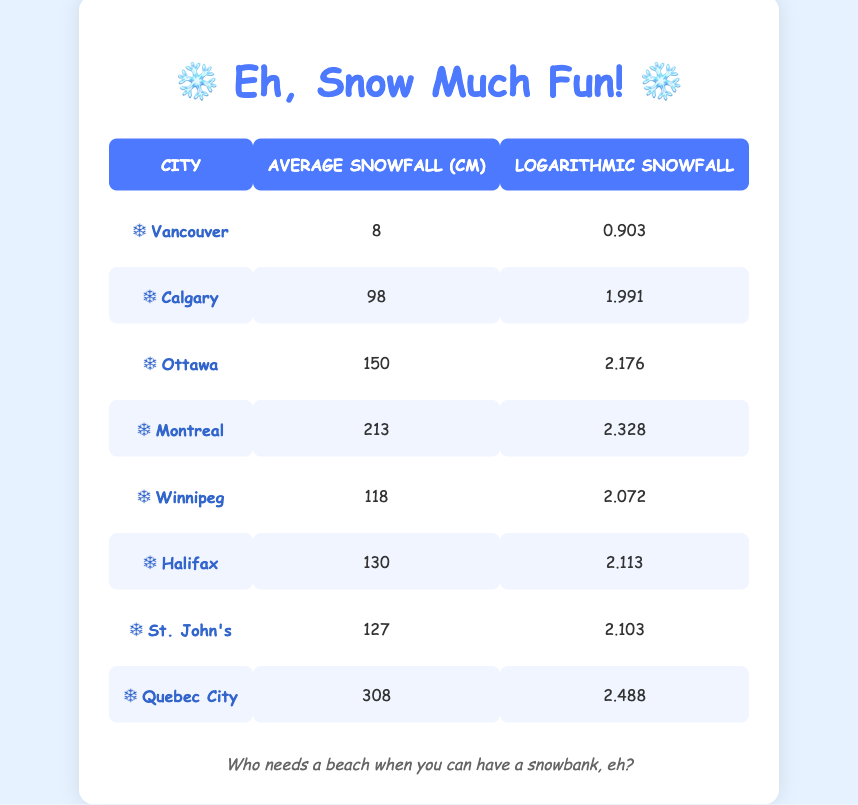What city has the highest average snowfall? By looking at the 'Average Snowfall (cm)' column, I can see that Quebec City has the highest average snowfall at 308 cm.
Answer: Quebec City What is the logarithmic snowfall value for Montreal? From the table, Montreal has a logarithmic snowfall value of 2.328.
Answer: 2.328 How much more average snowfall does Calgary have compared to Vancouver? Calgary has 98 cm of average snowfall while Vancouver has 8 cm. The difference is 98 - 8 = 90 cm.
Answer: 90 cm Is the average snowfall in Halifax greater than that in Ottawa? Halifax has an average snowfall of 130 cm and Ottawa has 150 cm. Since 130 is less than 150, the statement is false.
Answer: No Which city has a logarithmic snowfall value greater than 2? From the table, the cities with a logarithmic snowfall greater than 2 are Calgary (1.991), Ottawa (2.176), Montreal (2.328), Winnipeg (2.072), Halifax (2.113), St. John's (2.103), and Quebec City (2.488). Therefore, the answer is yes for Calgary, Ottawa, Montreal, Winnipeg, Halifax, St. John's, and Quebec City.
Answer: Yes What is the average snowfall of the three cities with the least snowfall (Vancouver, Calgary, and Winnipeg)? The average snowfall for Vancouver, Calgary, and Winnipeg can be calculated as: (8 + 98 + 118) / 3 = 224 / 3 = 74.67 cm.
Answer: 74.67 cm Which city has the second lowest logarithmic snowfall value? By examining the logarithmic values, Vancouver has 0.903 (the lowest), and Calgary follows with 1.991, making Calgary the second lowest.
Answer: Calgary Is the average snowfall in St. John's less than that in Halifax? St. John's has 127 cm of average snowfall and Halifax has 130 cm, so the statement is true since 127 is less than 130.
Answer: Yes What is the total average snowfall for all cities combined? To find the total average snowfall, I need to sum all the average snowfall values: 8 + 98 + 150 + 213 + 118 + 130 + 127 + 308 = 1,092 cm.
Answer: 1,092 cm 